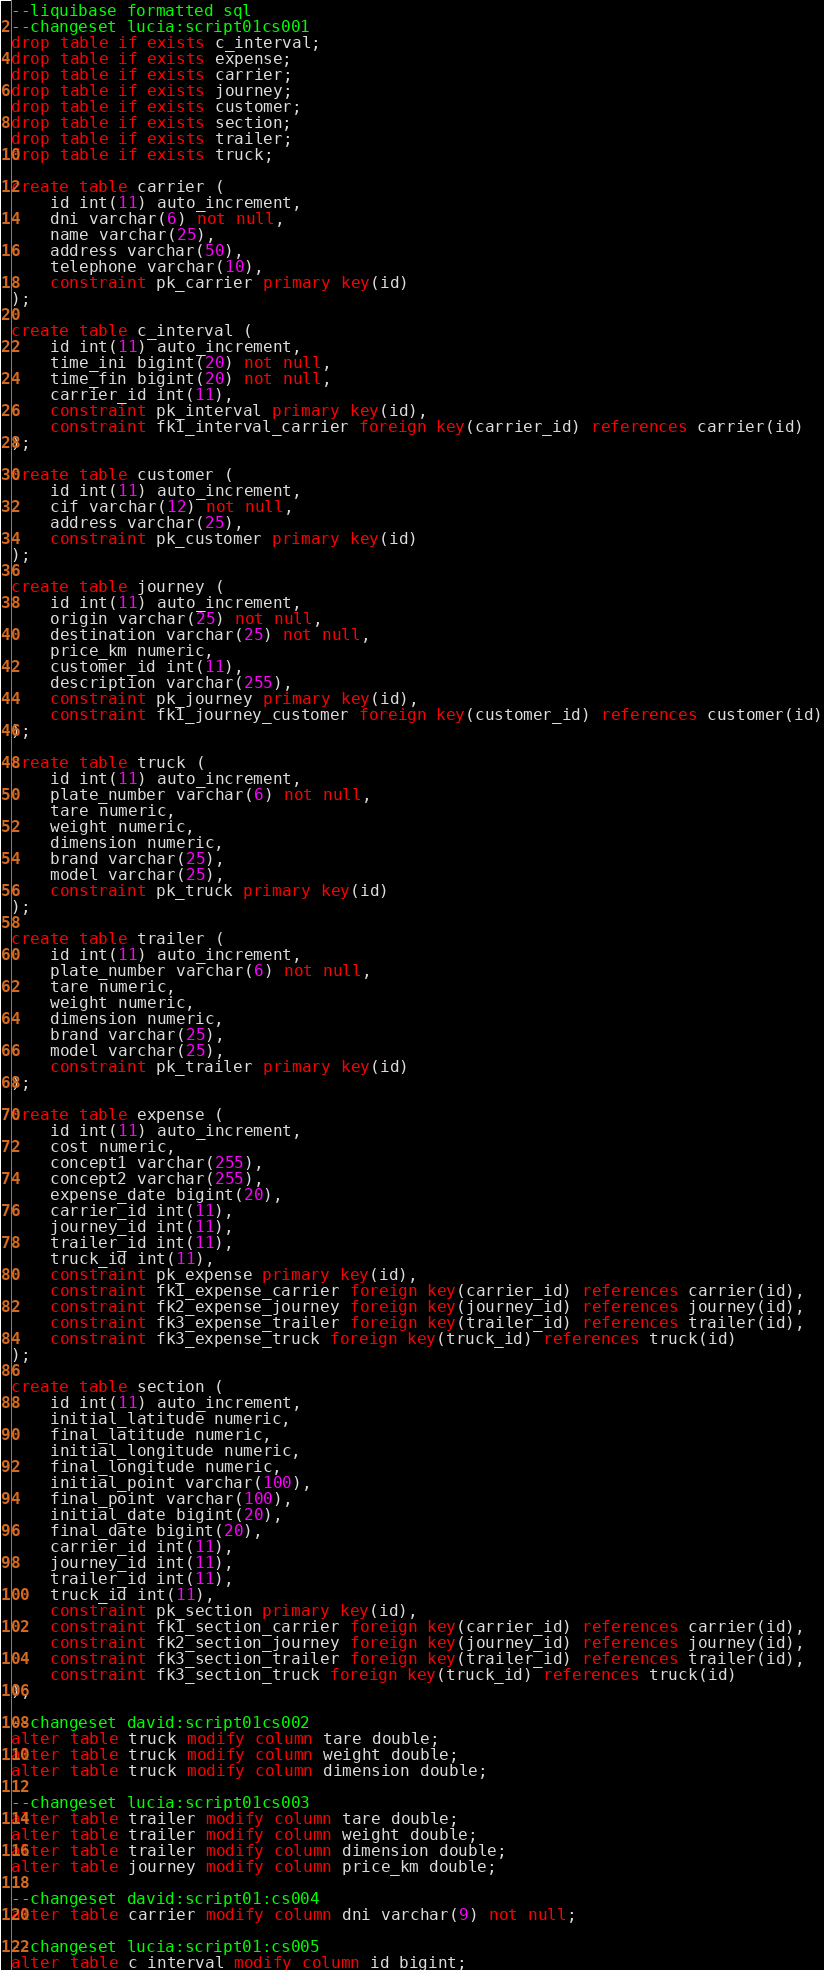<code> <loc_0><loc_0><loc_500><loc_500><_SQL_>--liquibase formatted sql
--changeset lucia:script01cs001
drop table if exists c_interval;
drop table if exists expense;
drop table if exists carrier;
drop table if exists journey;
drop table if exists customer;
drop table if exists section;
drop table if exists trailer;
drop table if exists truck;

create table carrier (
	id int(11) auto_increment,
	dni varchar(6) not null,
	name varchar(25),
	address varchar(50), 
	telephone varchar(10),
	constraint pk_carrier primary key(id)
);

create table c_interval (
	id int(11) auto_increment,
	time_ini bigint(20) not null,
	time_fin bigint(20) not null,
	carrier_id int(11), 
	constraint pk_interval primary key(id),
	constraint fk1_interval_carrier foreign key(carrier_id) references carrier(id)
);

create table customer (
	id int(11) auto_increment,
	cif varchar(12) not null,
	address varchar(25),
	constraint pk_customer primary key(id)	
);

create table journey (
	id int(11) auto_increment,
	origin varchar(25) not null,
	destination varchar(25) not null, 
	price_km numeric,
	customer_id int(11),
	description varchar(255),
	constraint pk_journey primary key(id),	
	constraint fk1_journey_customer foreign key(customer_id) references customer(id)
);

create table truck (
	id int(11) auto_increment,
	plate_number varchar(6) not null,
	tare numeric,
	weight numeric, 
	dimension numeric,
	brand varchar(25),
	model varchar(25),
	constraint pk_truck primary key(id)	
);

create table trailer (
	id int(11) auto_increment,
	plate_number varchar(6) not null,
	tare numeric,
	weight numeric, 
	dimension numeric,
	brand varchar(25),
	model varchar(25),
	constraint pk_trailer primary key(id)	
);

create table expense (
	id int(11) auto_increment,
	cost numeric,
	concept1 varchar(255),
	concept2 varchar(255),
	expense_date bigint(20),
	carrier_id int(11),
	journey_id int(11),
	trailer_id int(11),
	truck_id int(11),
	constraint pk_expense primary key(id),
	constraint fk1_expense_carrier foreign key(carrier_id) references carrier(id),
	constraint fk2_expense_journey foreign key(journey_id) references journey(id),
	constraint fk3_expense_trailer foreign key(trailer_id) references trailer(id),
	constraint fk3_expense_truck foreign key(truck_id) references truck(id)
);

create table section (
	id int(11) auto_increment,
	initial_latitude numeric,
	final_latitude numeric,
	initial_longitude numeric,
	final_longitude numeric,
	initial_point varchar(100),
	final_point varchar(100),
	initial_date bigint(20),
	final_date bigint(20),
	carrier_id int(11),
	journey_id int(11),
	trailer_id int(11),
	truck_id int(11),
	constraint pk_section primary key(id),
	constraint fk1_section_carrier foreign key(carrier_id) references carrier(id),
	constraint fk2_section_journey foreign key(journey_id) references journey(id),
	constraint fk3_section_trailer foreign key(trailer_id) references trailer(id),
	constraint fk3_section_truck foreign key(truck_id) references truck(id)
);

--changeset david:script01cs002
alter table truck modify column tare double;
alter table truck modify column weight double;
alter table truck modify column dimension double;

--changeset lucia:script01cs003
alter table trailer modify column tare double;
alter table trailer modify column weight double;
alter table trailer modify column dimension double;
alter table journey modify column price_km double;

--changeset david:script01:cs004
alter table carrier modify column dni varchar(9) not null;

--changeset lucia:script01:cs005
alter table c_interval modify column id bigint;</code> 